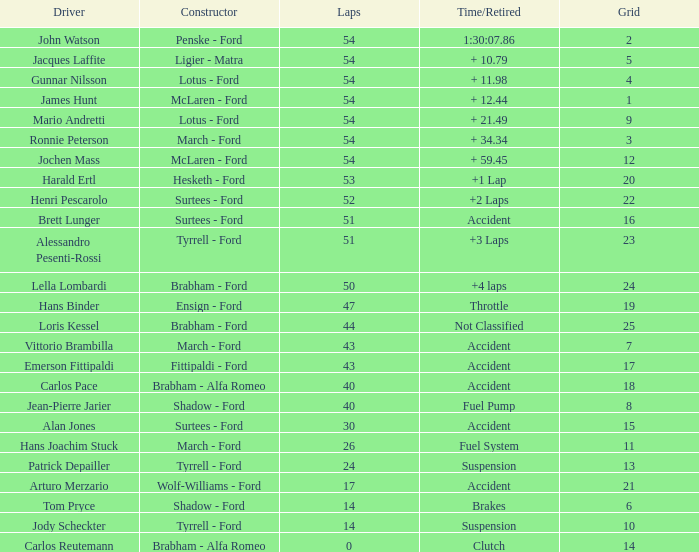What is the Time/Retired of Carlos Reutemann who was driving a brabham - Alfa Romeo? Clutch. Can you give me this table as a dict? {'header': ['Driver', 'Constructor', 'Laps', 'Time/Retired', 'Grid'], 'rows': [['John Watson', 'Penske - Ford', '54', '1:30:07.86', '2'], ['Jacques Laffite', 'Ligier - Matra', '54', '+ 10.79', '5'], ['Gunnar Nilsson', 'Lotus - Ford', '54', '+ 11.98', '4'], ['James Hunt', 'McLaren - Ford', '54', '+ 12.44', '1'], ['Mario Andretti', 'Lotus - Ford', '54', '+ 21.49', '9'], ['Ronnie Peterson', 'March - Ford', '54', '+ 34.34', '3'], ['Jochen Mass', 'McLaren - Ford', '54', '+ 59.45', '12'], ['Harald Ertl', 'Hesketh - Ford', '53', '+1 Lap', '20'], ['Henri Pescarolo', 'Surtees - Ford', '52', '+2 Laps', '22'], ['Brett Lunger', 'Surtees - Ford', '51', 'Accident', '16'], ['Alessandro Pesenti-Rossi', 'Tyrrell - Ford', '51', '+3 Laps', '23'], ['Lella Lombardi', 'Brabham - Ford', '50', '+4 laps', '24'], ['Hans Binder', 'Ensign - Ford', '47', 'Throttle', '19'], ['Loris Kessel', 'Brabham - Ford', '44', 'Not Classified', '25'], ['Vittorio Brambilla', 'March - Ford', '43', 'Accident', '7'], ['Emerson Fittipaldi', 'Fittipaldi - Ford', '43', 'Accident', '17'], ['Carlos Pace', 'Brabham - Alfa Romeo', '40', 'Accident', '18'], ['Jean-Pierre Jarier', 'Shadow - Ford', '40', 'Fuel Pump', '8'], ['Alan Jones', 'Surtees - Ford', '30', 'Accident', '15'], ['Hans Joachim Stuck', 'March - Ford', '26', 'Fuel System', '11'], ['Patrick Depailler', 'Tyrrell - Ford', '24', 'Suspension', '13'], ['Arturo Merzario', 'Wolf-Williams - Ford', '17', 'Accident', '21'], ['Tom Pryce', 'Shadow - Ford', '14', 'Brakes', '6'], ['Jody Scheckter', 'Tyrrell - Ford', '14', 'Suspension', '10'], ['Carlos Reutemann', 'Brabham - Alfa Romeo', '0', 'Clutch', '14']]} 